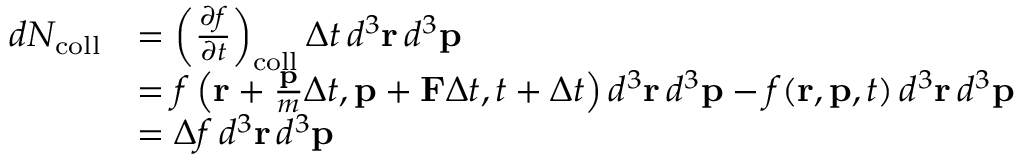<formula> <loc_0><loc_0><loc_500><loc_500>{ \begin{array} { r l } { d N _ { c o l l } } & { = \left ( { \frac { \partial f } { \partial t } } \right ) _ { c o l l } \Delta t \, d ^ { 3 } r \, d ^ { 3 } p } \\ & { = f \left ( r + { \frac { p } { m } } \Delta t , p + F \Delta t , t + \Delta t \right ) d ^ { 3 } r \, d ^ { 3 } p - f ( r , p , t ) \, d ^ { 3 } r \, d ^ { 3 } p } \\ & { = \Delta f \, d ^ { 3 } r \, d ^ { 3 } p } \end{array} }</formula> 